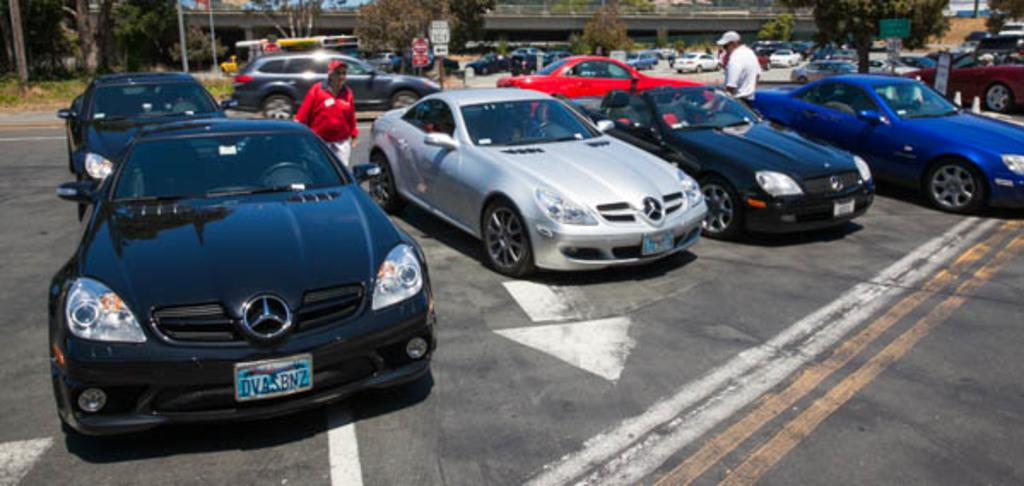What can be seen on the road in the image? There are vehicles on the road in the image. Who or what else can be seen in the image? There are people visible in the image. What is on the pole in the image? There are sign boards on the pole in the image. What is in the background of the image? There is a bridge and trees visible in the background of the image. What type of polish is being applied to the dinosaurs in the image? There are no dinosaurs present in the image, so there is no polish being applied to them. Are there any pets visible in the image? There is no mention of pets in the provided facts, so we cannot determine if any pets are visible in the image. 